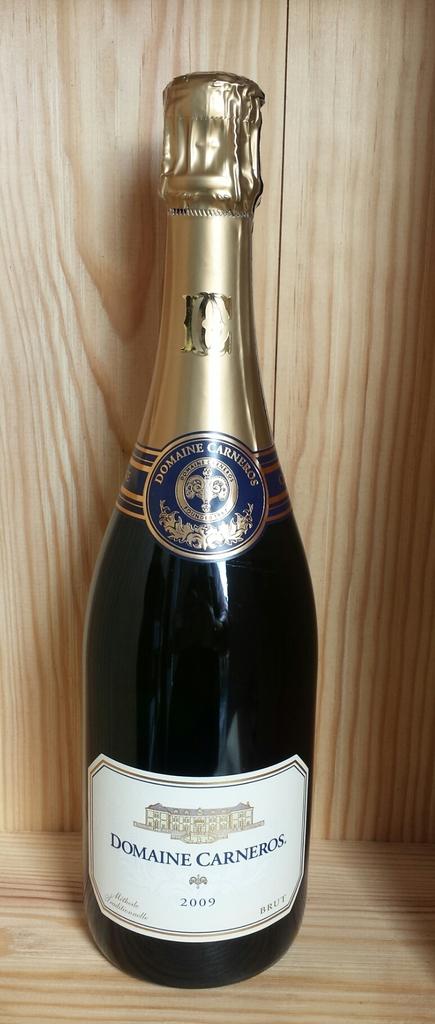What year has this wine aged from?
Offer a very short reply. 2009. What is the name of the wine?
Ensure brevity in your answer.  Domaine carneros. 